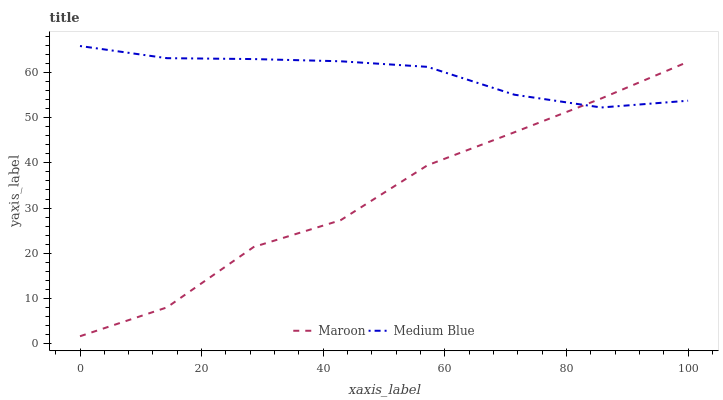Does Maroon have the minimum area under the curve?
Answer yes or no. Yes. Does Medium Blue have the maximum area under the curve?
Answer yes or no. Yes. Does Maroon have the maximum area under the curve?
Answer yes or no. No. Is Medium Blue the smoothest?
Answer yes or no. Yes. Is Maroon the roughest?
Answer yes or no. Yes. Is Maroon the smoothest?
Answer yes or no. No. Does Maroon have the lowest value?
Answer yes or no. Yes. Does Medium Blue have the highest value?
Answer yes or no. Yes. Does Maroon have the highest value?
Answer yes or no. No. Does Maroon intersect Medium Blue?
Answer yes or no. Yes. Is Maroon less than Medium Blue?
Answer yes or no. No. Is Maroon greater than Medium Blue?
Answer yes or no. No. 